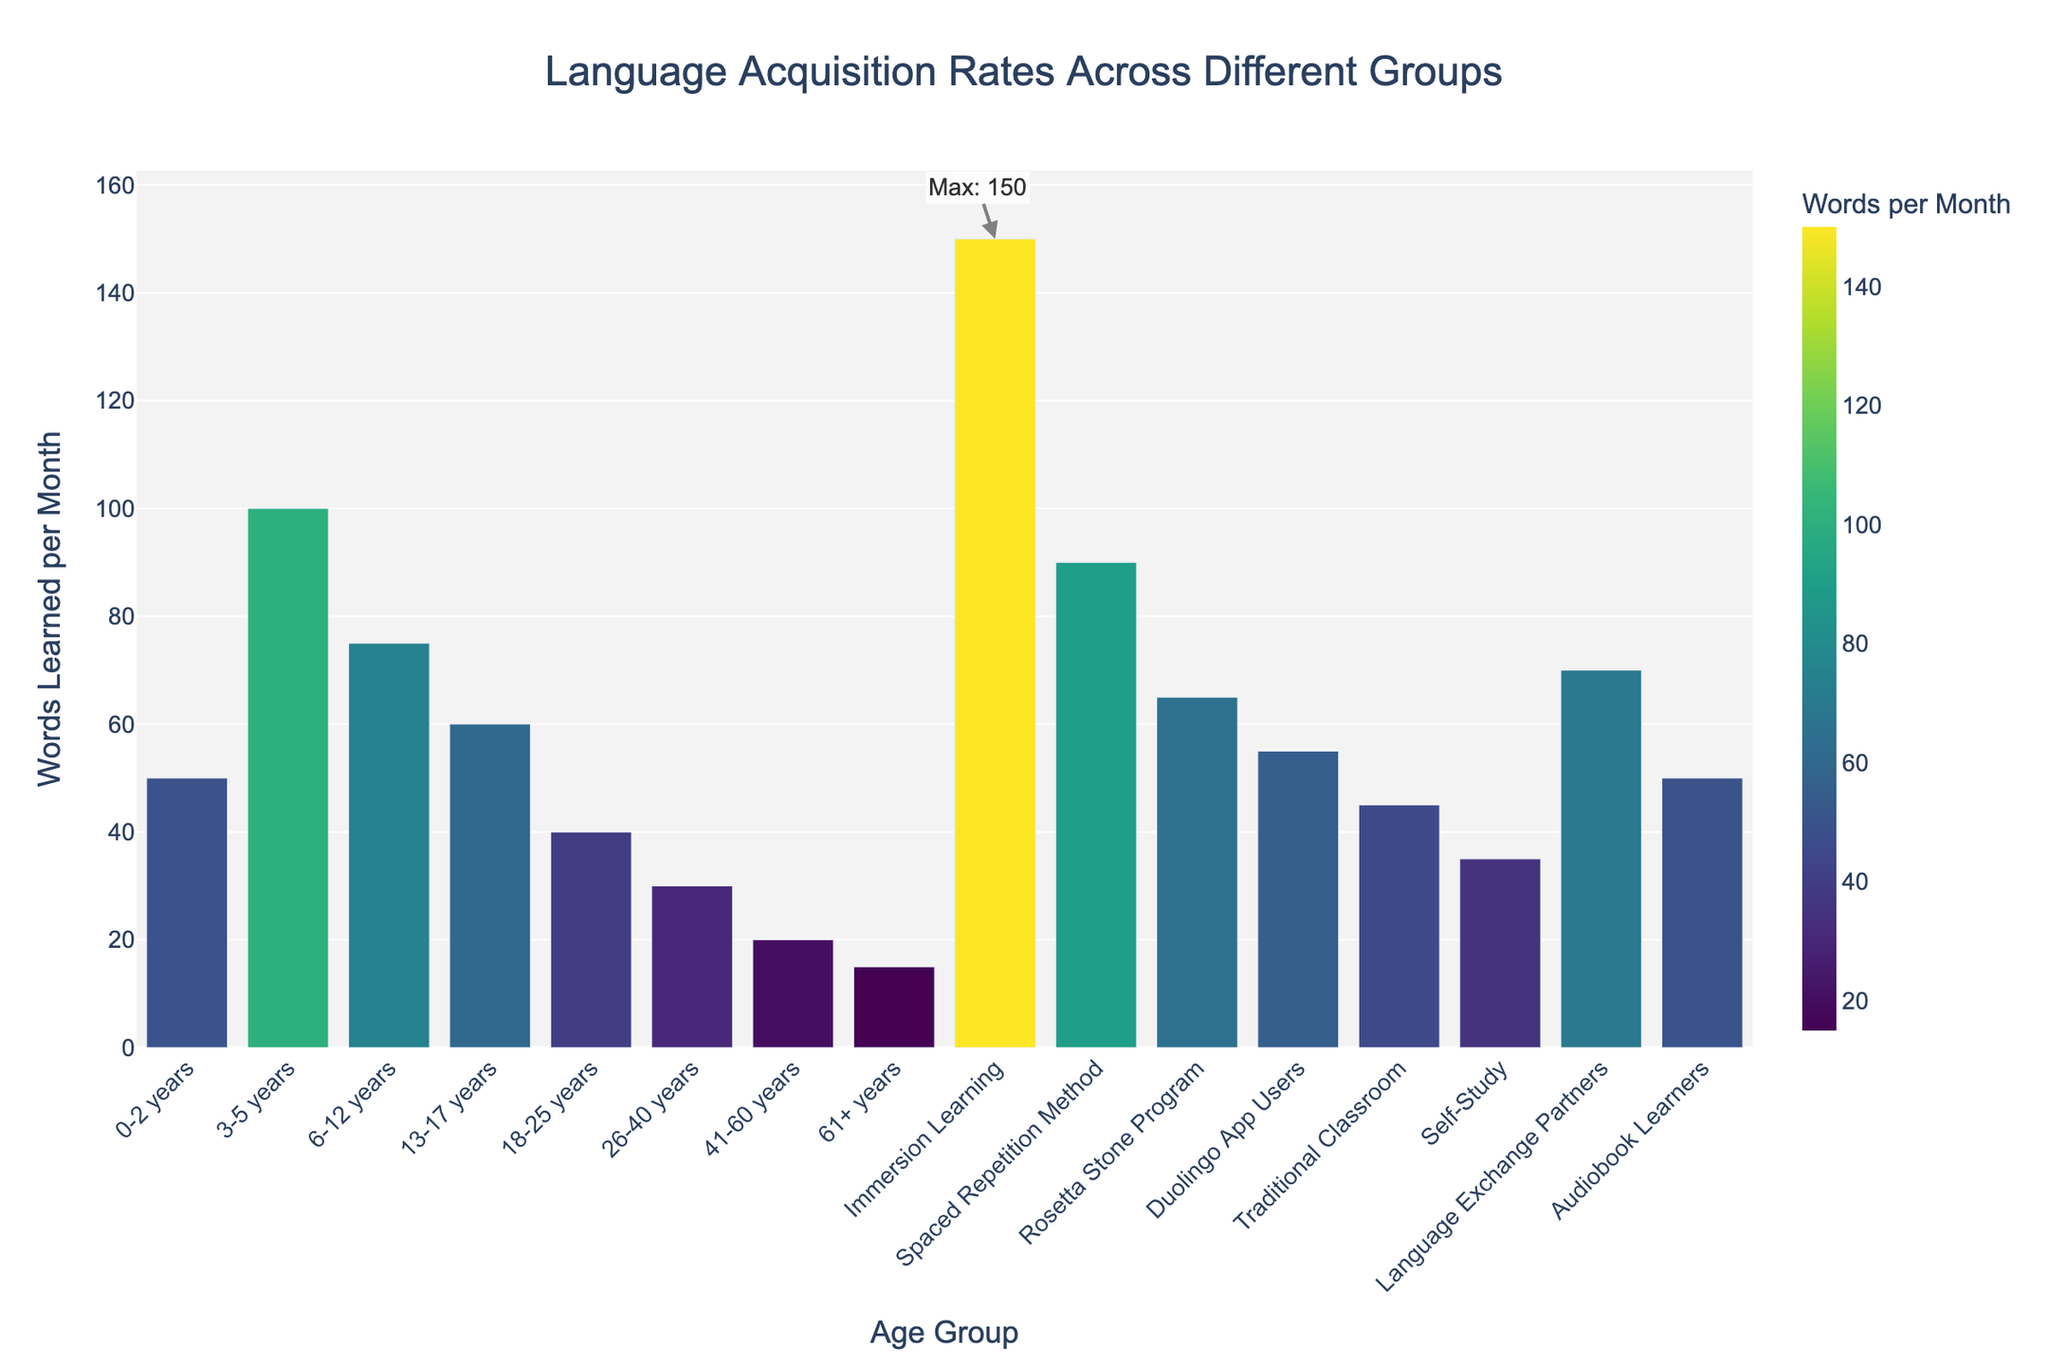What age group's language acquisition rate is higher: 6-12 years or 18-25 years? The bar for the 6-12 years age group is taller than the bar for the 18-25 years age group. The figure shows 75 words per month for 6-12 years, while it shows 40 words per month for 18-25 years.
Answer: 6-12 years Which learning method has the highest language acquisition rate? The highest bar on the chart represents "Immersion Learning," with a rate of 150 words per month.
Answer: Immersion Learning What is the total number of words learned per month by the 0-2 years, 3-5 years, and 6-12 years groups combined? Sum the words learned per month for these age groups: 50 (0-2 years) + 100 (3-5 years) + 75 (6-12 years) = 225 words.
Answer: 225 Compare the language acquisition rate of Rosetta Stone Program to Duolingo App Users. Which is higher and by how much? The Rosetta Stone Program has a rate of 65 words per month, while Duolingo App Users learn 55 words per month. So, Rosetta Stone is higher by 65 - 55 = 10 words per month.
Answer: Rosetta Stone Program, 10 Which age group has the lowest language acquisition rate? The shortest bar among age groups is the "61+ years" group, with 15 words learned per month.
Answer: 61+ years What is the difference in language acquisition rate between the highest age group and the lowest age group? The highest age group for language acquisition is the 3-5 years group at 100 words per month. The lowest is the 61+ years group at 15 words per month. The difference is 100 - 15 = 85 words per month.
Answer: 85 Calculate the average language acquisition rate for all the listed age groups. Sum the words learned per month for all age groups and divide by the number of age groups: (50 + 100 + 75 + 60 + 40 + 30 + 20 + 15) / 8 = 390 / 8 = 48.75 words per month.
Answer: 48.75 Among learning methods, which one has an acquisition rate closest to the average rate of all listed age groups? The average rate of age groups is 48.75 words per month. The "Audiobook Learners" method, which has a rate of 50 words per month, is closest to this average.
Answer: Audiobook Learners How does the language acquisition rate of Traditional Classroom compare to the Self-Study method? The Traditional Classroom method has an acquisition rate of 45 words per month, while Self-Study has 35 words per month. The Traditional Classroom rate is higher by 10 words per month.
Answer: Traditional Classroom, 10 